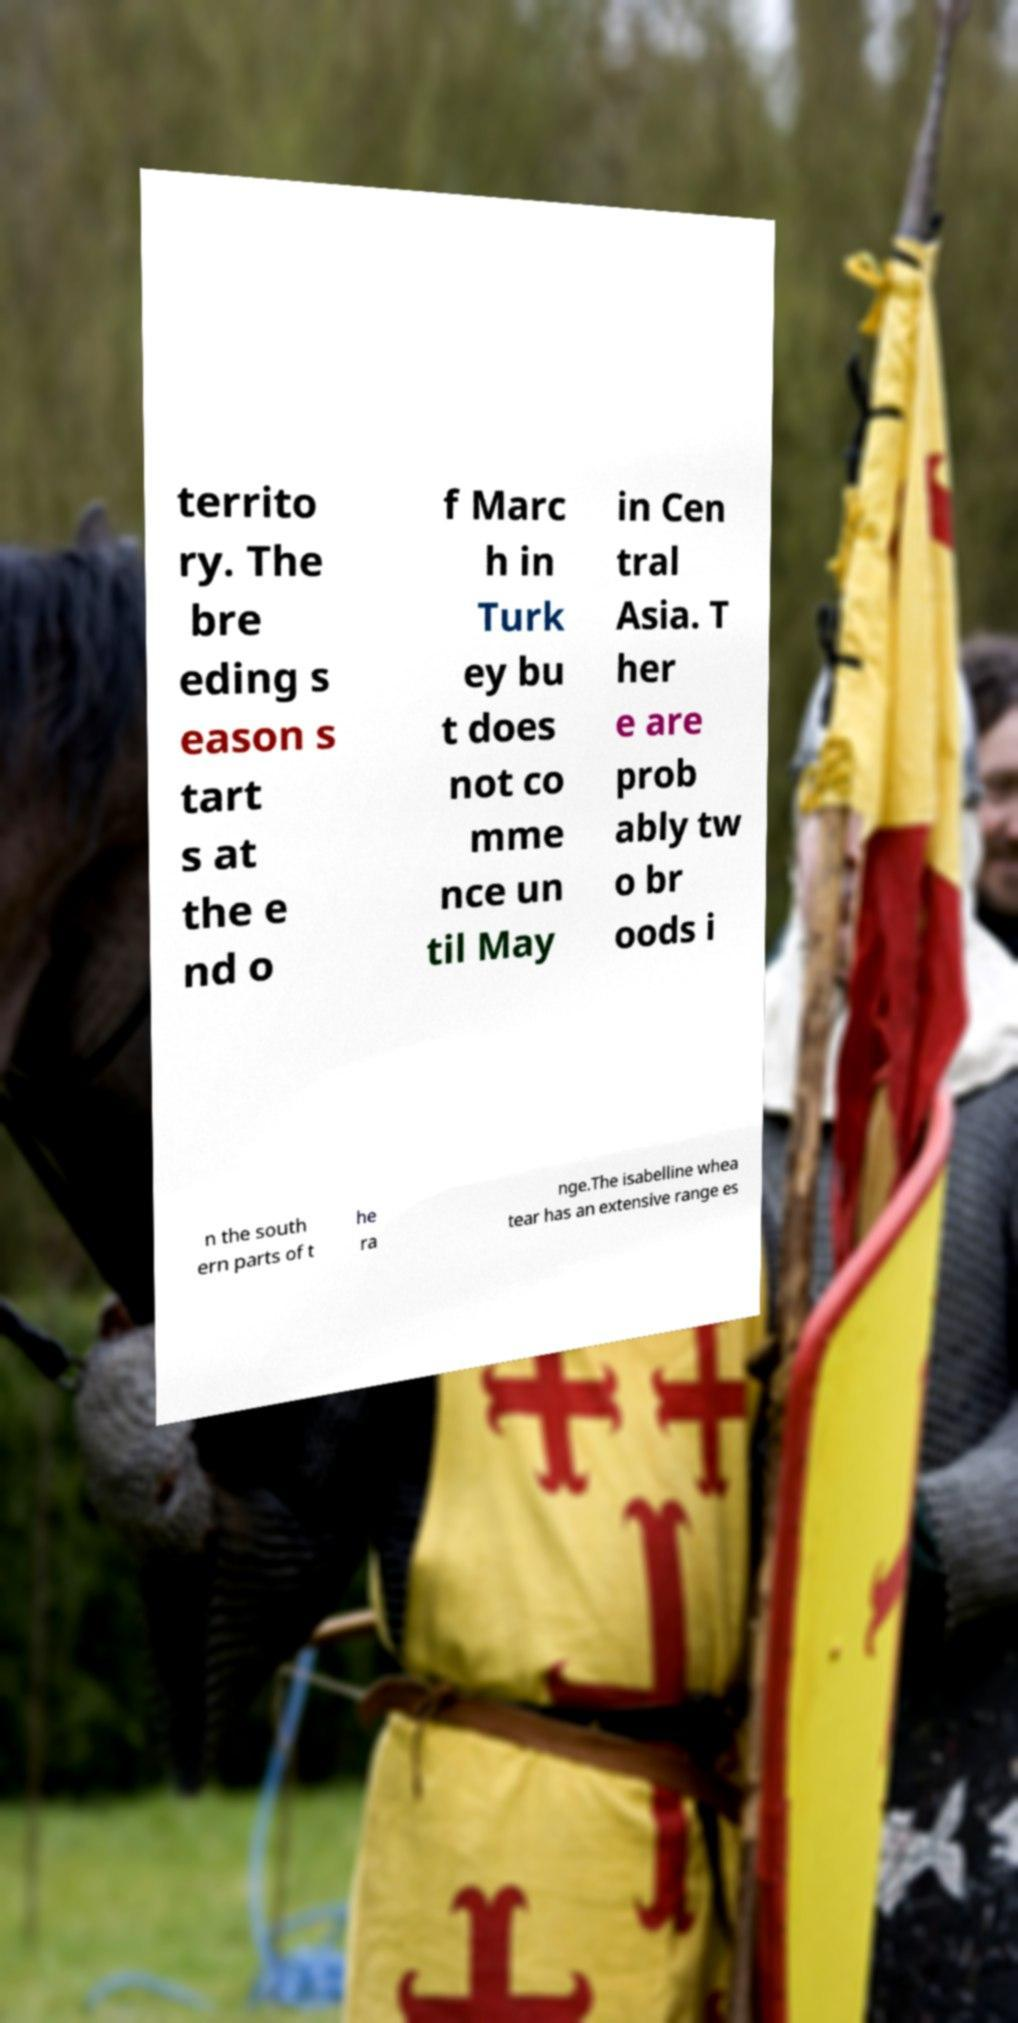Please read and relay the text visible in this image. What does it say? territo ry. The bre eding s eason s tart s at the e nd o f Marc h in Turk ey bu t does not co mme nce un til May in Cen tral Asia. T her e are prob ably tw o br oods i n the south ern parts of t he ra nge.The isabelline whea tear has an extensive range es 